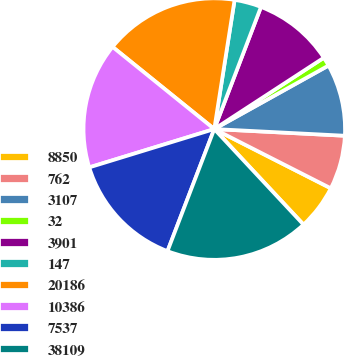Convert chart to OTSL. <chart><loc_0><loc_0><loc_500><loc_500><pie_chart><fcel>8850<fcel>762<fcel>3107<fcel>32<fcel>3901<fcel>147<fcel>20186<fcel>10386<fcel>7537<fcel>38109<nl><fcel>5.56%<fcel>6.67%<fcel>8.89%<fcel>1.11%<fcel>10.0%<fcel>3.33%<fcel>16.67%<fcel>15.55%<fcel>14.44%<fcel>17.78%<nl></chart> 